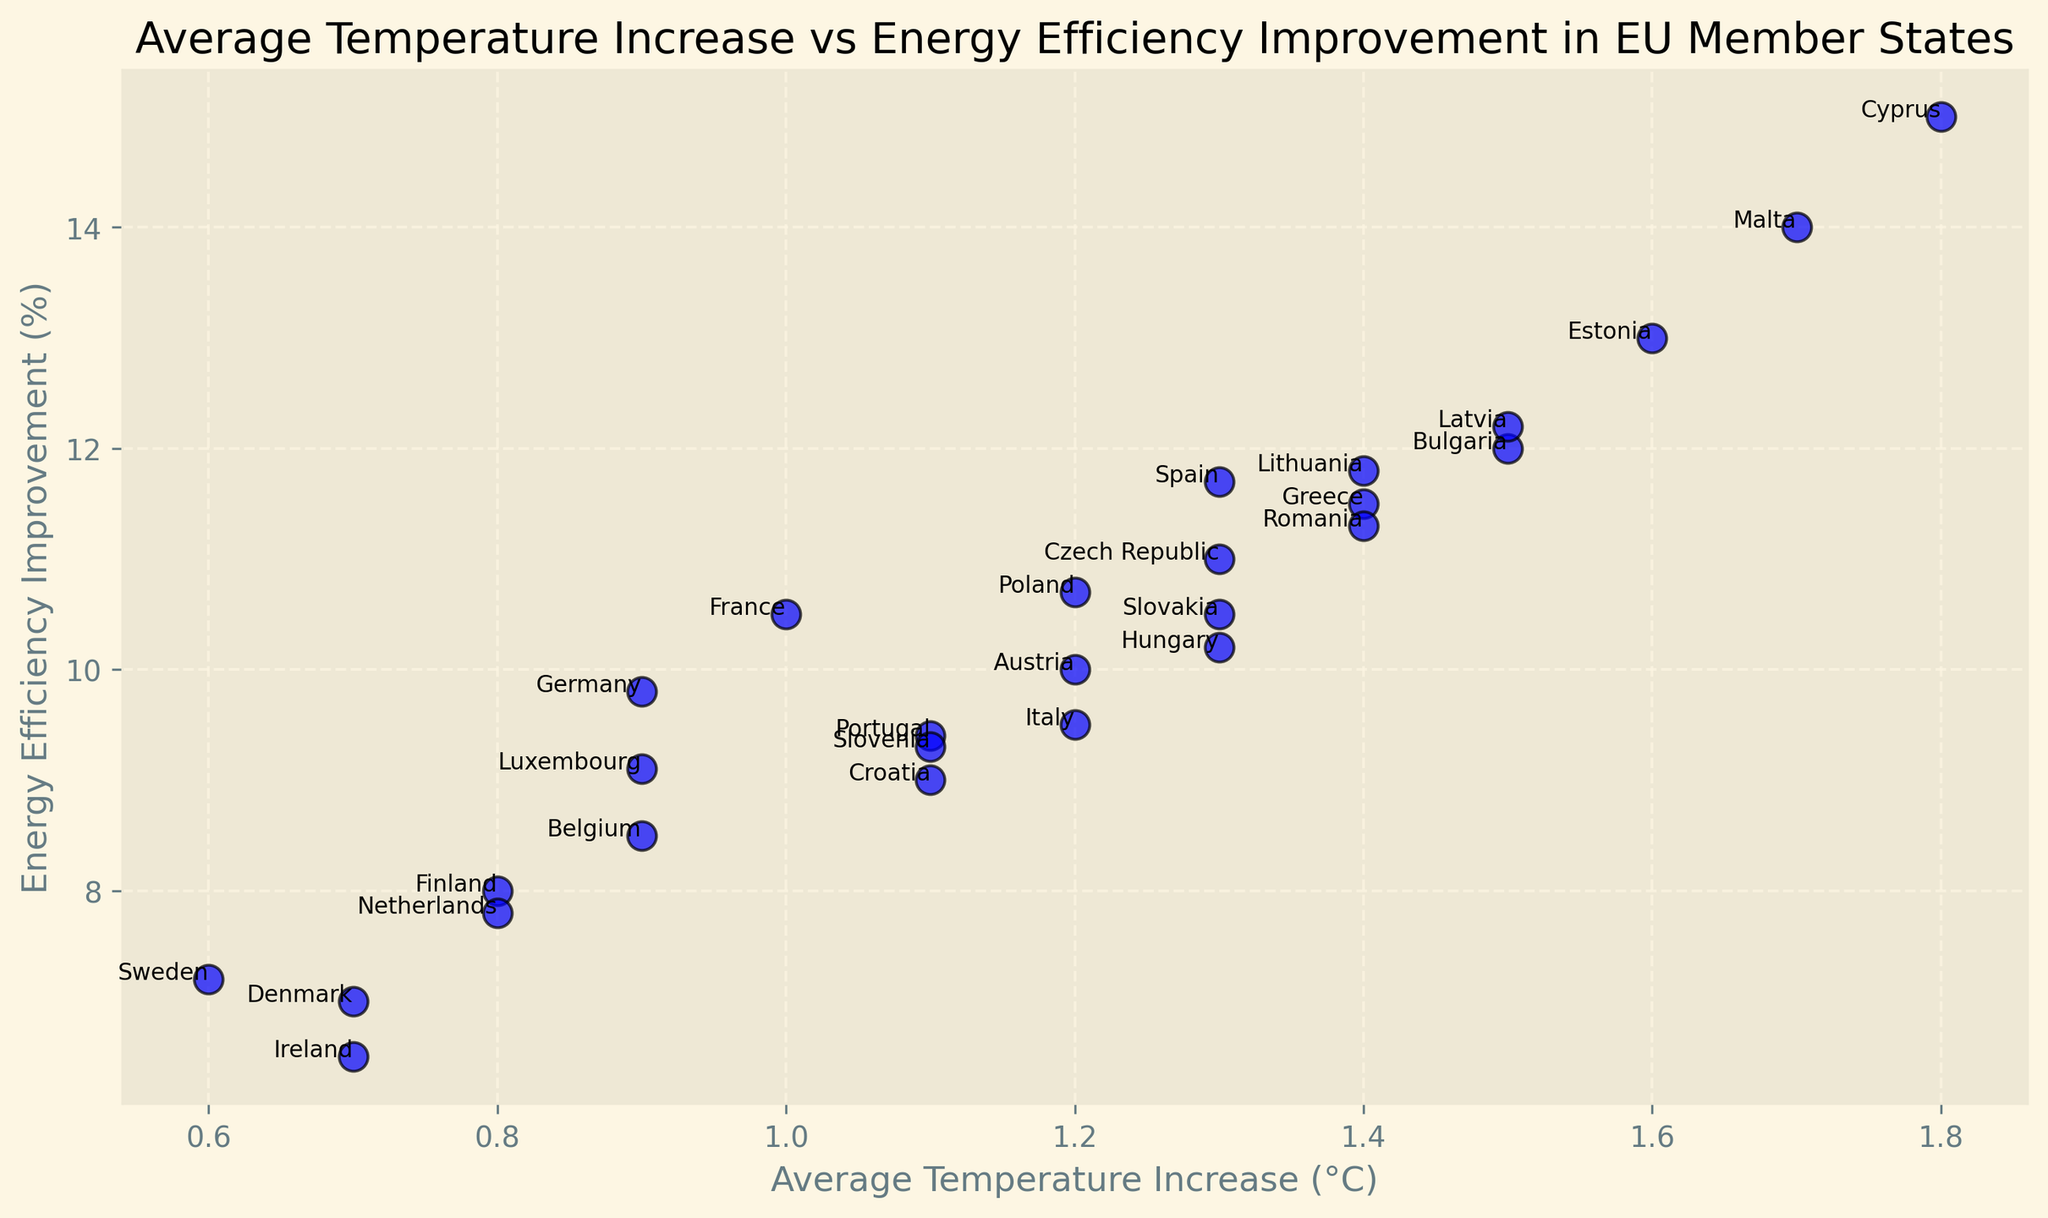Which country shows the highest energy efficiency improvement? Identify the dot that has the highest y-value. The label next to this dot shows the country.
Answer: Cyprus What is the energy efficiency improvement percentage for Austria? Locate the dot labeled 'Austria' on the plot and check its corresponding y-axis value.
Answer: 10% Which countries have an average temperature increase greater than 1.5°C? Look at the dots with x-values greater than 1.5 and note the country labels beside them.
Answer: Bulgaria, Cyprus, Estonia, Malta Among Denmark and Sweden, which country has a higher energy efficiency improvement? Compare the y-values of the dots labeled 'Denmark' and 'Sweden'.
Answer: Denmark What's the average temperature increase difference between the Netherlands and Finland? Find the x-values for 'Netherlands' and 'Finland' and calculate the difference: 0.8°C - 0.8°C.
Answer: 0.0°C How many countries have an energy efficiency improvement percentage above 12%? Count the number of dots that have y-values greater than 12 and identify their country labels.
Answer: 6 countries: Bulgaria, Cyprus, Estonia, Malta, Latvia, Spain What is the overall trend between average temperature increase and energy efficiency improvement? Visually inspect the scatter plot for any noticeable pattern or trend between x and y values.
Answer: Positive correlation What is the temperature increase for Romania, and how does it compare to the EU average provided in non-graph data? Locate the 'Romania' dot and note the x-value, then compare this value in the context of average temperature increase.
Answer: 1.4°C Which has a higher energy efficiency improvement: Luxembourg or Germany? Compare the y-axis values of the dots labeled 'Luxembourg' and 'Germany'.
Answer: Germany Which country has the lowest average temperature increase and what is it? Identify the dot with the minimum x-value and note the corresponding country label and value.
Answer: Sweden, 0.6°C 